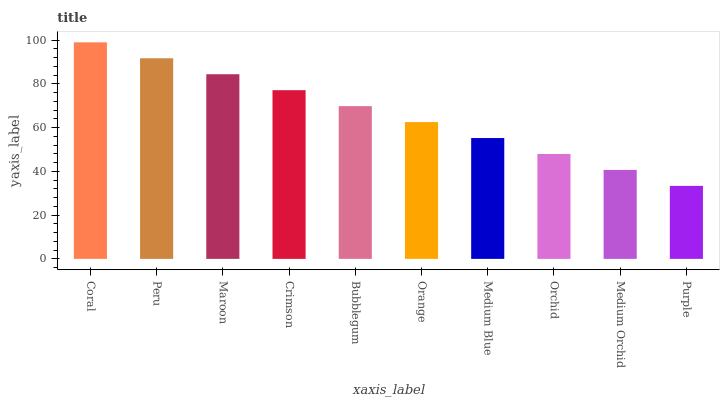Is Peru the minimum?
Answer yes or no. No. Is Peru the maximum?
Answer yes or no. No. Is Coral greater than Peru?
Answer yes or no. Yes. Is Peru less than Coral?
Answer yes or no. Yes. Is Peru greater than Coral?
Answer yes or no. No. Is Coral less than Peru?
Answer yes or no. No. Is Bubblegum the high median?
Answer yes or no. Yes. Is Orange the low median?
Answer yes or no. Yes. Is Coral the high median?
Answer yes or no. No. Is Purple the low median?
Answer yes or no. No. 